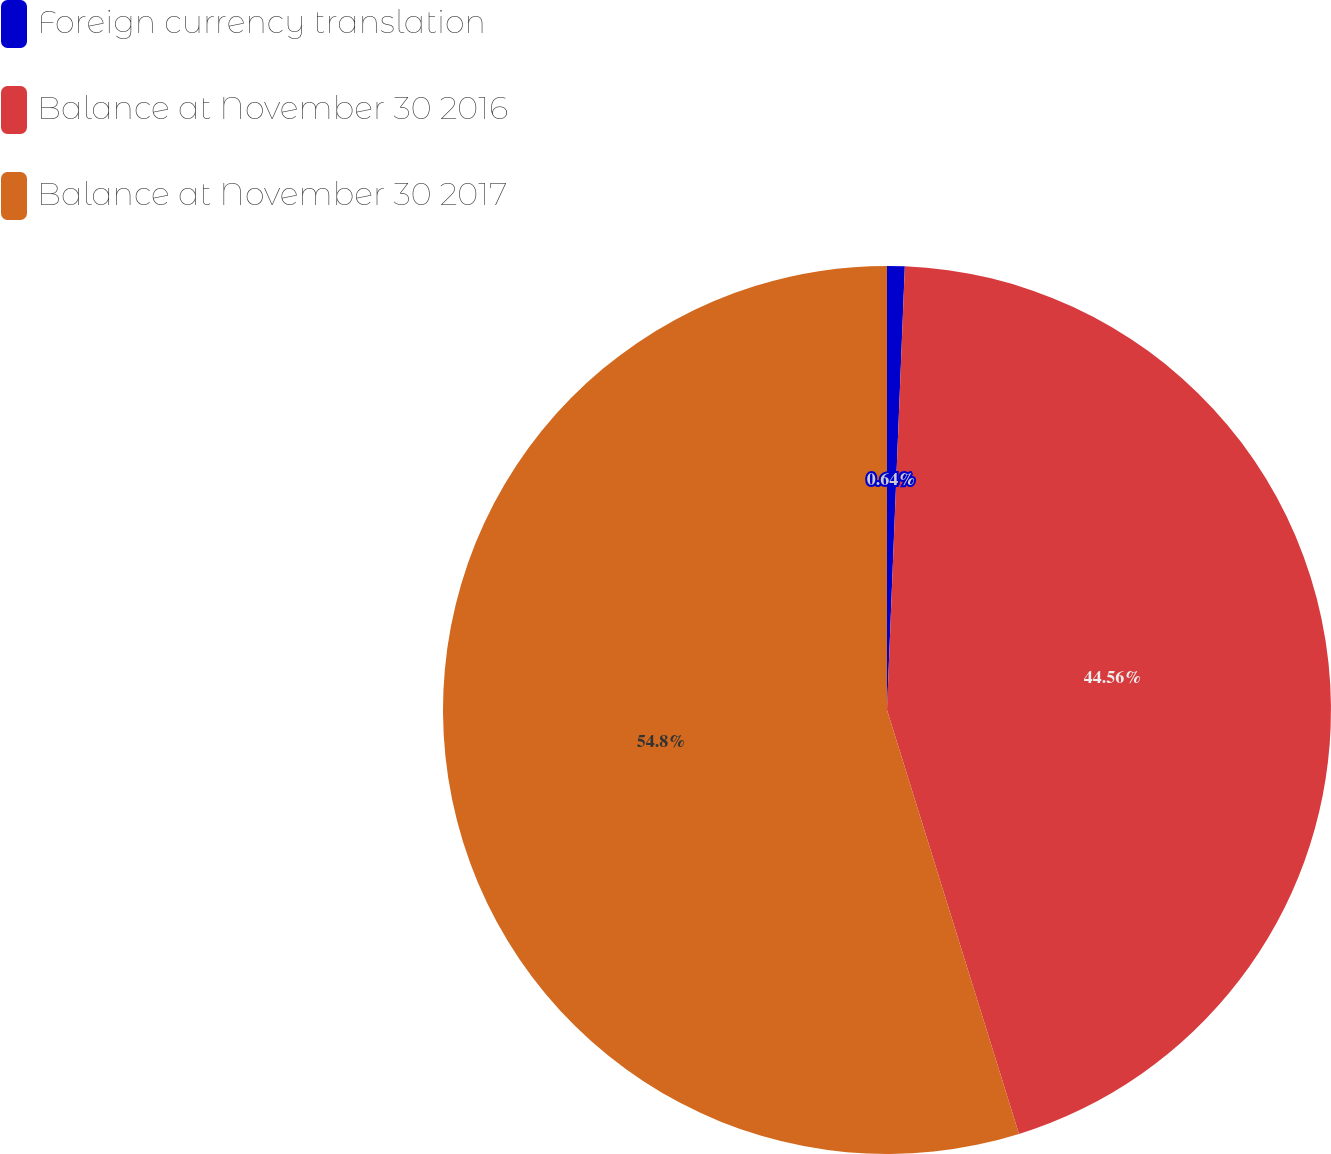<chart> <loc_0><loc_0><loc_500><loc_500><pie_chart><fcel>Foreign currency translation<fcel>Balance at November 30 2016<fcel>Balance at November 30 2017<nl><fcel>0.64%<fcel>44.56%<fcel>54.81%<nl></chart> 